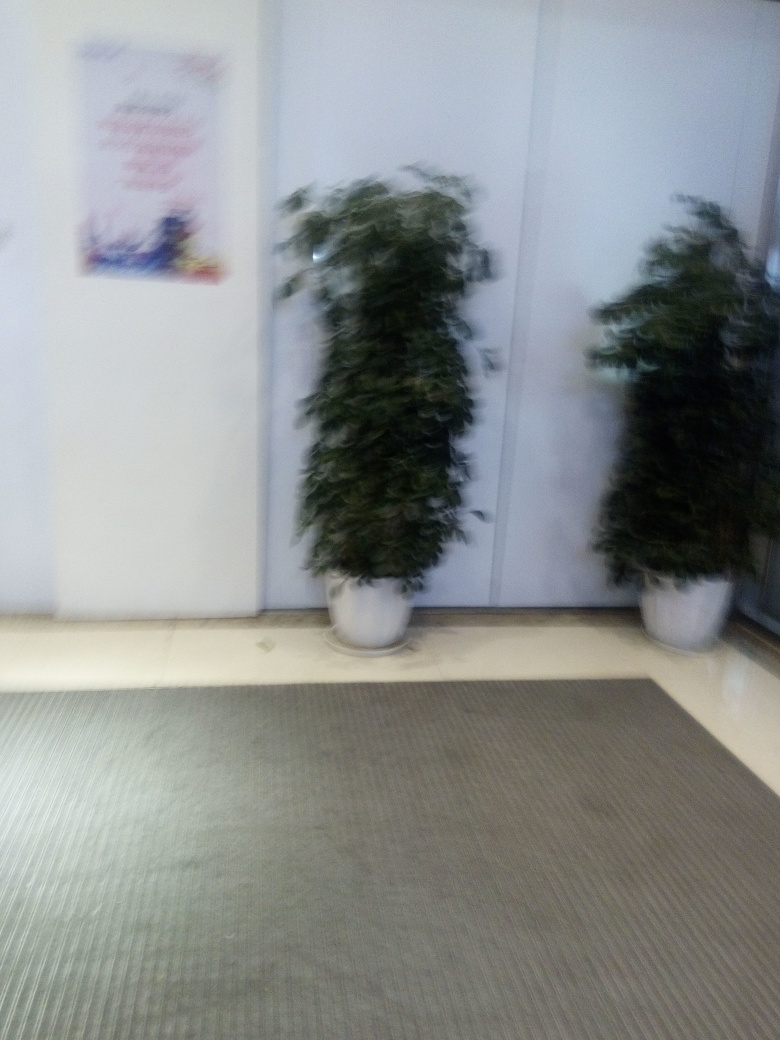Could this photo have artistic value despite its low quality? Absolutely, artistic value is subjective and can transcend technical imperfections. The blurred effect in this photo can create a sense of movement or dreaminess that might align with an artist’s vision. It can evoke emotions or suggest a storyline beyond what is immediately visible. Sometimes, a photo's aesthetic or emotional impact is more significant than its technical quality. 